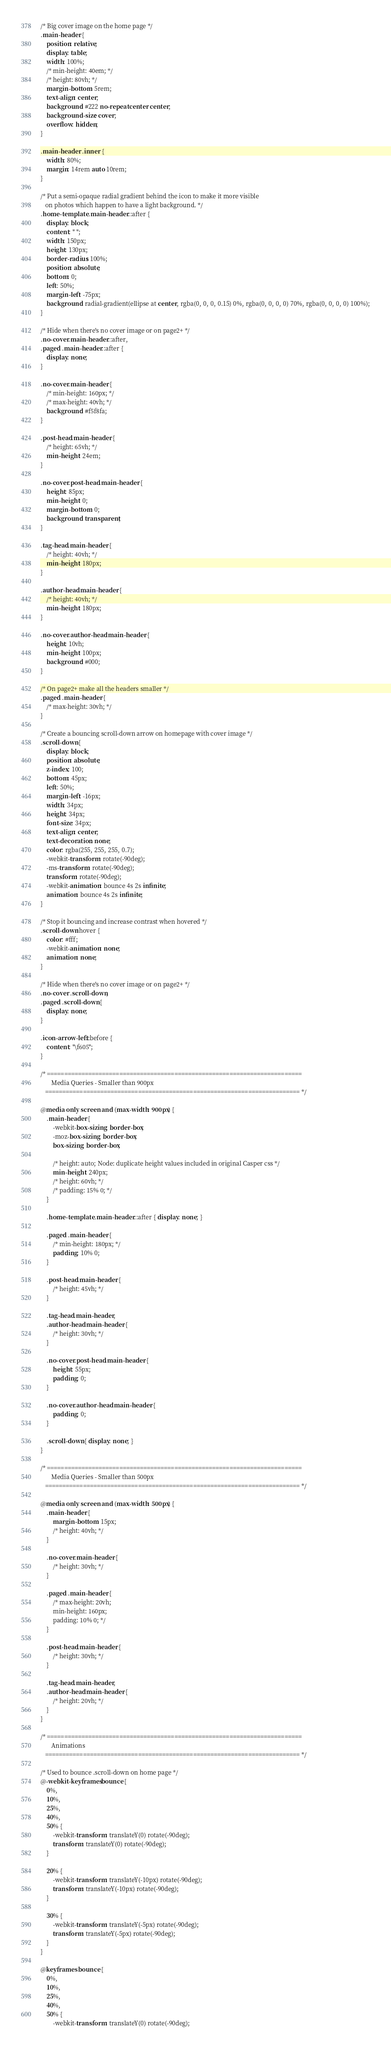Convert code to text. <code><loc_0><loc_0><loc_500><loc_500><_CSS_>/* Big cover image on the home page */
.main-header {
    position: relative;
    display: table;
    width: 100%;
    /* min-height: 40em; */
    /* height: 80vh; */
    margin-bottom: 5rem;
    text-align: center;
    background: #222 no-repeat center center;
    background-size: cover;
    overflow: hidden;
}

.main-header .inner {
    width: 80%;
    margin: 14rem auto 10rem;
}

/* Put a semi-opaque radial gradient behind the icon to make it more visible
   on photos which happen to have a light background. */
.home-template .main-header::after {
    display: block;
    content: " ";
    width: 150px;
    height: 130px;
    border-radius: 100%;
    position: absolute;
    bottom: 0;
    left: 50%;
    margin-left: -75px;
    background: radial-gradient(ellipse at center, rgba(0, 0, 0, 0.15) 0%, rgba(0, 0, 0, 0) 70%, rgba(0, 0, 0, 0) 100%);
}

/* Hide when there's no cover image or on page2+ */
.no-cover.main-header::after,
.paged .main-header::after {
    display: none;
}

.no-cover.main-header {
    /* min-height: 160px; */
    /* max-height: 40vh; */
    background: #f5f8fa;
}

.post-head.main-header {
    /* height: 65vh; */
    min-height: 24em;
}

.no-cover.post-head.main-header {
    height: 85px;
    min-height: 0;
    margin-bottom: 0;
    background: transparent;
}

.tag-head.main-header {
    /* height: 40vh; */
    min-height: 180px;
}

.author-head.main-header {
    /* height: 40vh; */
    min-height: 180px;
}

.no-cover.author-head.main-header {
    height: 10vh;
    min-height: 100px;
    background: #000;
}

/* On page2+ make all the headers smaller */
.paged .main-header {
    /* max-height: 30vh; */
}

/* Create a bouncing scroll-down arrow on homepage with cover image */
.scroll-down {
    display: block;
    position: absolute;
    z-index: 100;
    bottom: 45px;
    left: 50%;
    margin-left: -16px;
    width: 34px;
    height: 34px;
    font-size: 34px;
    text-align: center;
    text-decoration: none;
    color: rgba(255, 255, 255, 0.7);
    -webkit-transform: rotate(-90deg);
    -ms-transform: rotate(-90deg);
    transform: rotate(-90deg);
    -webkit-animation: bounce 4s 2s infinite;
    animation: bounce 4s 2s infinite;
}

/* Stop it bouncing and increase contrast when hovered */
.scroll-down:hover {
    color: #fff;
    -webkit-animation: none;
    animation: none;
}

/* Hide when there's no cover image or on page2+ */
.no-cover .scroll-down,
.paged .scroll-down {
    display: none;
}

.icon-arrow-left::before {
    content: "\f605";
}

/* ==========================================================================
       Media Queries - Smaller than 900px
   ========================================================================== */

@media only screen and (max-width: 900px) {
    .main-header {
        -webkit-box-sizing: border-box;
        -moz-box-sizing: border-box;
        box-sizing: border-box;

        /* height: auto; Node: duplicate height values included in original Casper css */
        min-height: 240px;
        /* height: 60vh; */
        /* padding: 15% 0; */
    }

    .home-template .main-header::after { display: none; }

    .paged .main-header {
        /* min-height: 180px; */
        padding: 10% 0;
    }

    .post-head.main-header {
        /* height: 45vh; */
    }

    .tag-head.main-header,
    .author-head.main-header {
        /* height: 30vh; */
    }

    .no-cover.post-head.main-header {
        height: 55px;
        padding: 0;
    }

    .no-cover.author-head.main-header {
        padding: 0;
    }

    .scroll-down { display: none; }
}

/* ==========================================================================
       Media Queries - Smaller than 500px
   ========================================================================== */

@media only screen and (max-width: 500px) {
    .main-header {
        margin-bottom: 15px;
        /* height: 40vh; */
    }

    .no-cover.main-header {
        /* height: 30vh; */
    }

    .paged .main-header {
        /* max-height: 20vh;
        min-height: 160px;
        padding: 10% 0; */
    }

    .post-head.main-header {
        /* height: 30vh; */
    }

    .tag-head.main-header,
    .author-head.main-header {
        /* height: 20vh; */
    }
}

/* ==========================================================================
       Animations
   ========================================================================== */

/* Used to bounce .scroll-down on home page */
@-webkit-keyframes bounce {
    0%,
    10%,
    25%,
    40%,
    50% {
        -webkit-transform: translateY(0) rotate(-90deg);
        transform: translateY(0) rotate(-90deg);
    }

    20% {
        -webkit-transform: translateY(-10px) rotate(-90deg);
        transform: translateY(-10px) rotate(-90deg);
    }

    30% {
        -webkit-transform: translateY(-5px) rotate(-90deg);
        transform: translateY(-5px) rotate(-90deg);
    }
}

@keyframes bounce {
    0%,
    10%,
    25%,
    40%,
    50% {
        -webkit-transform: translateY(0) rotate(-90deg);</code> 